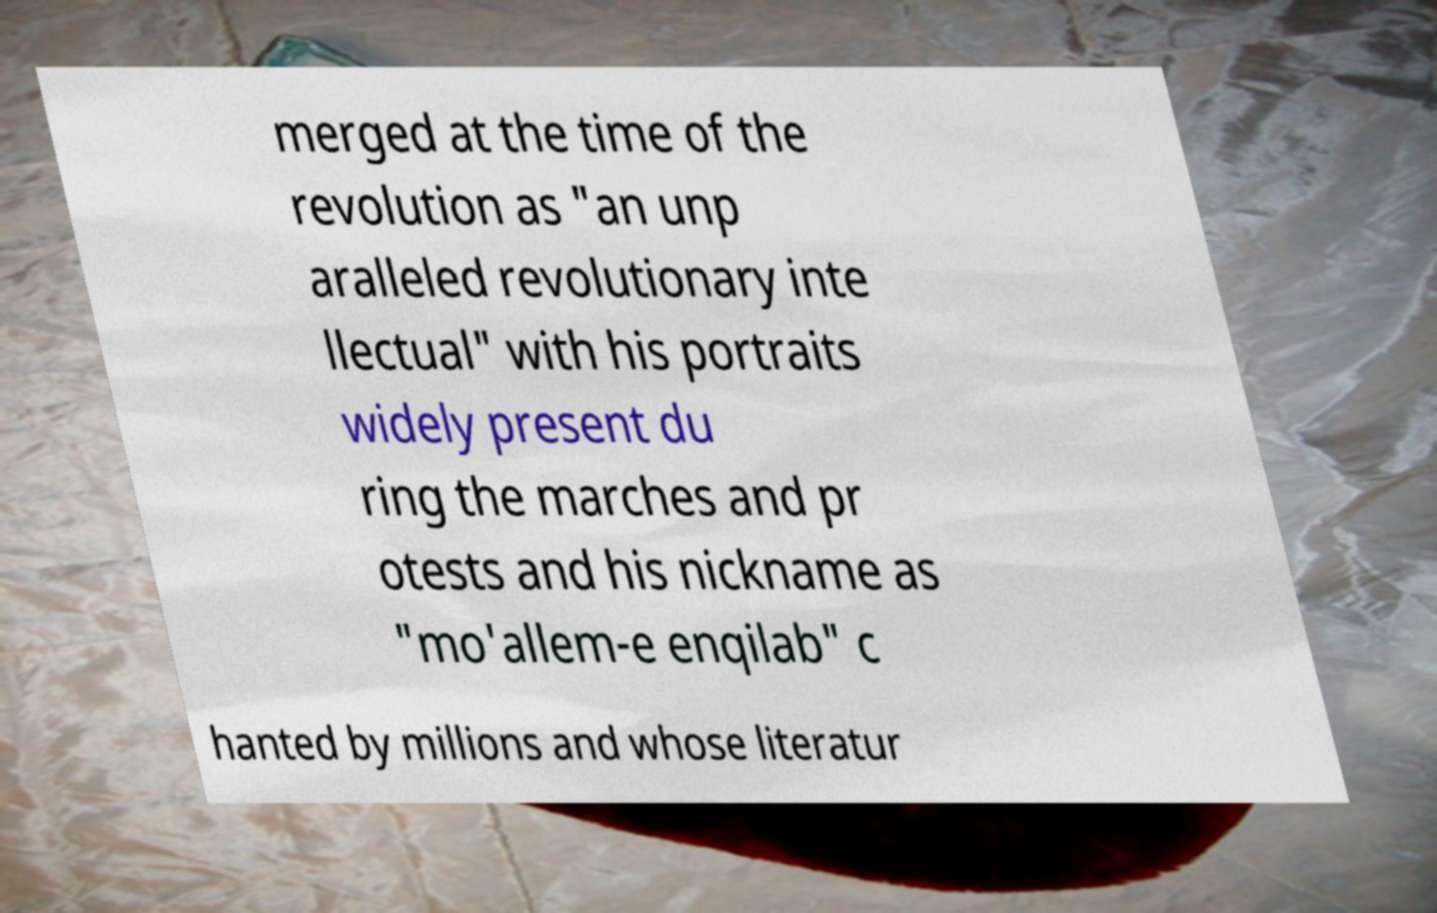There's text embedded in this image that I need extracted. Can you transcribe it verbatim? merged at the time of the revolution as "an unp aralleled revolutionary inte llectual" with his portraits widely present du ring the marches and pr otests and his nickname as "mo'allem-e enqilab" c hanted by millions and whose literatur 